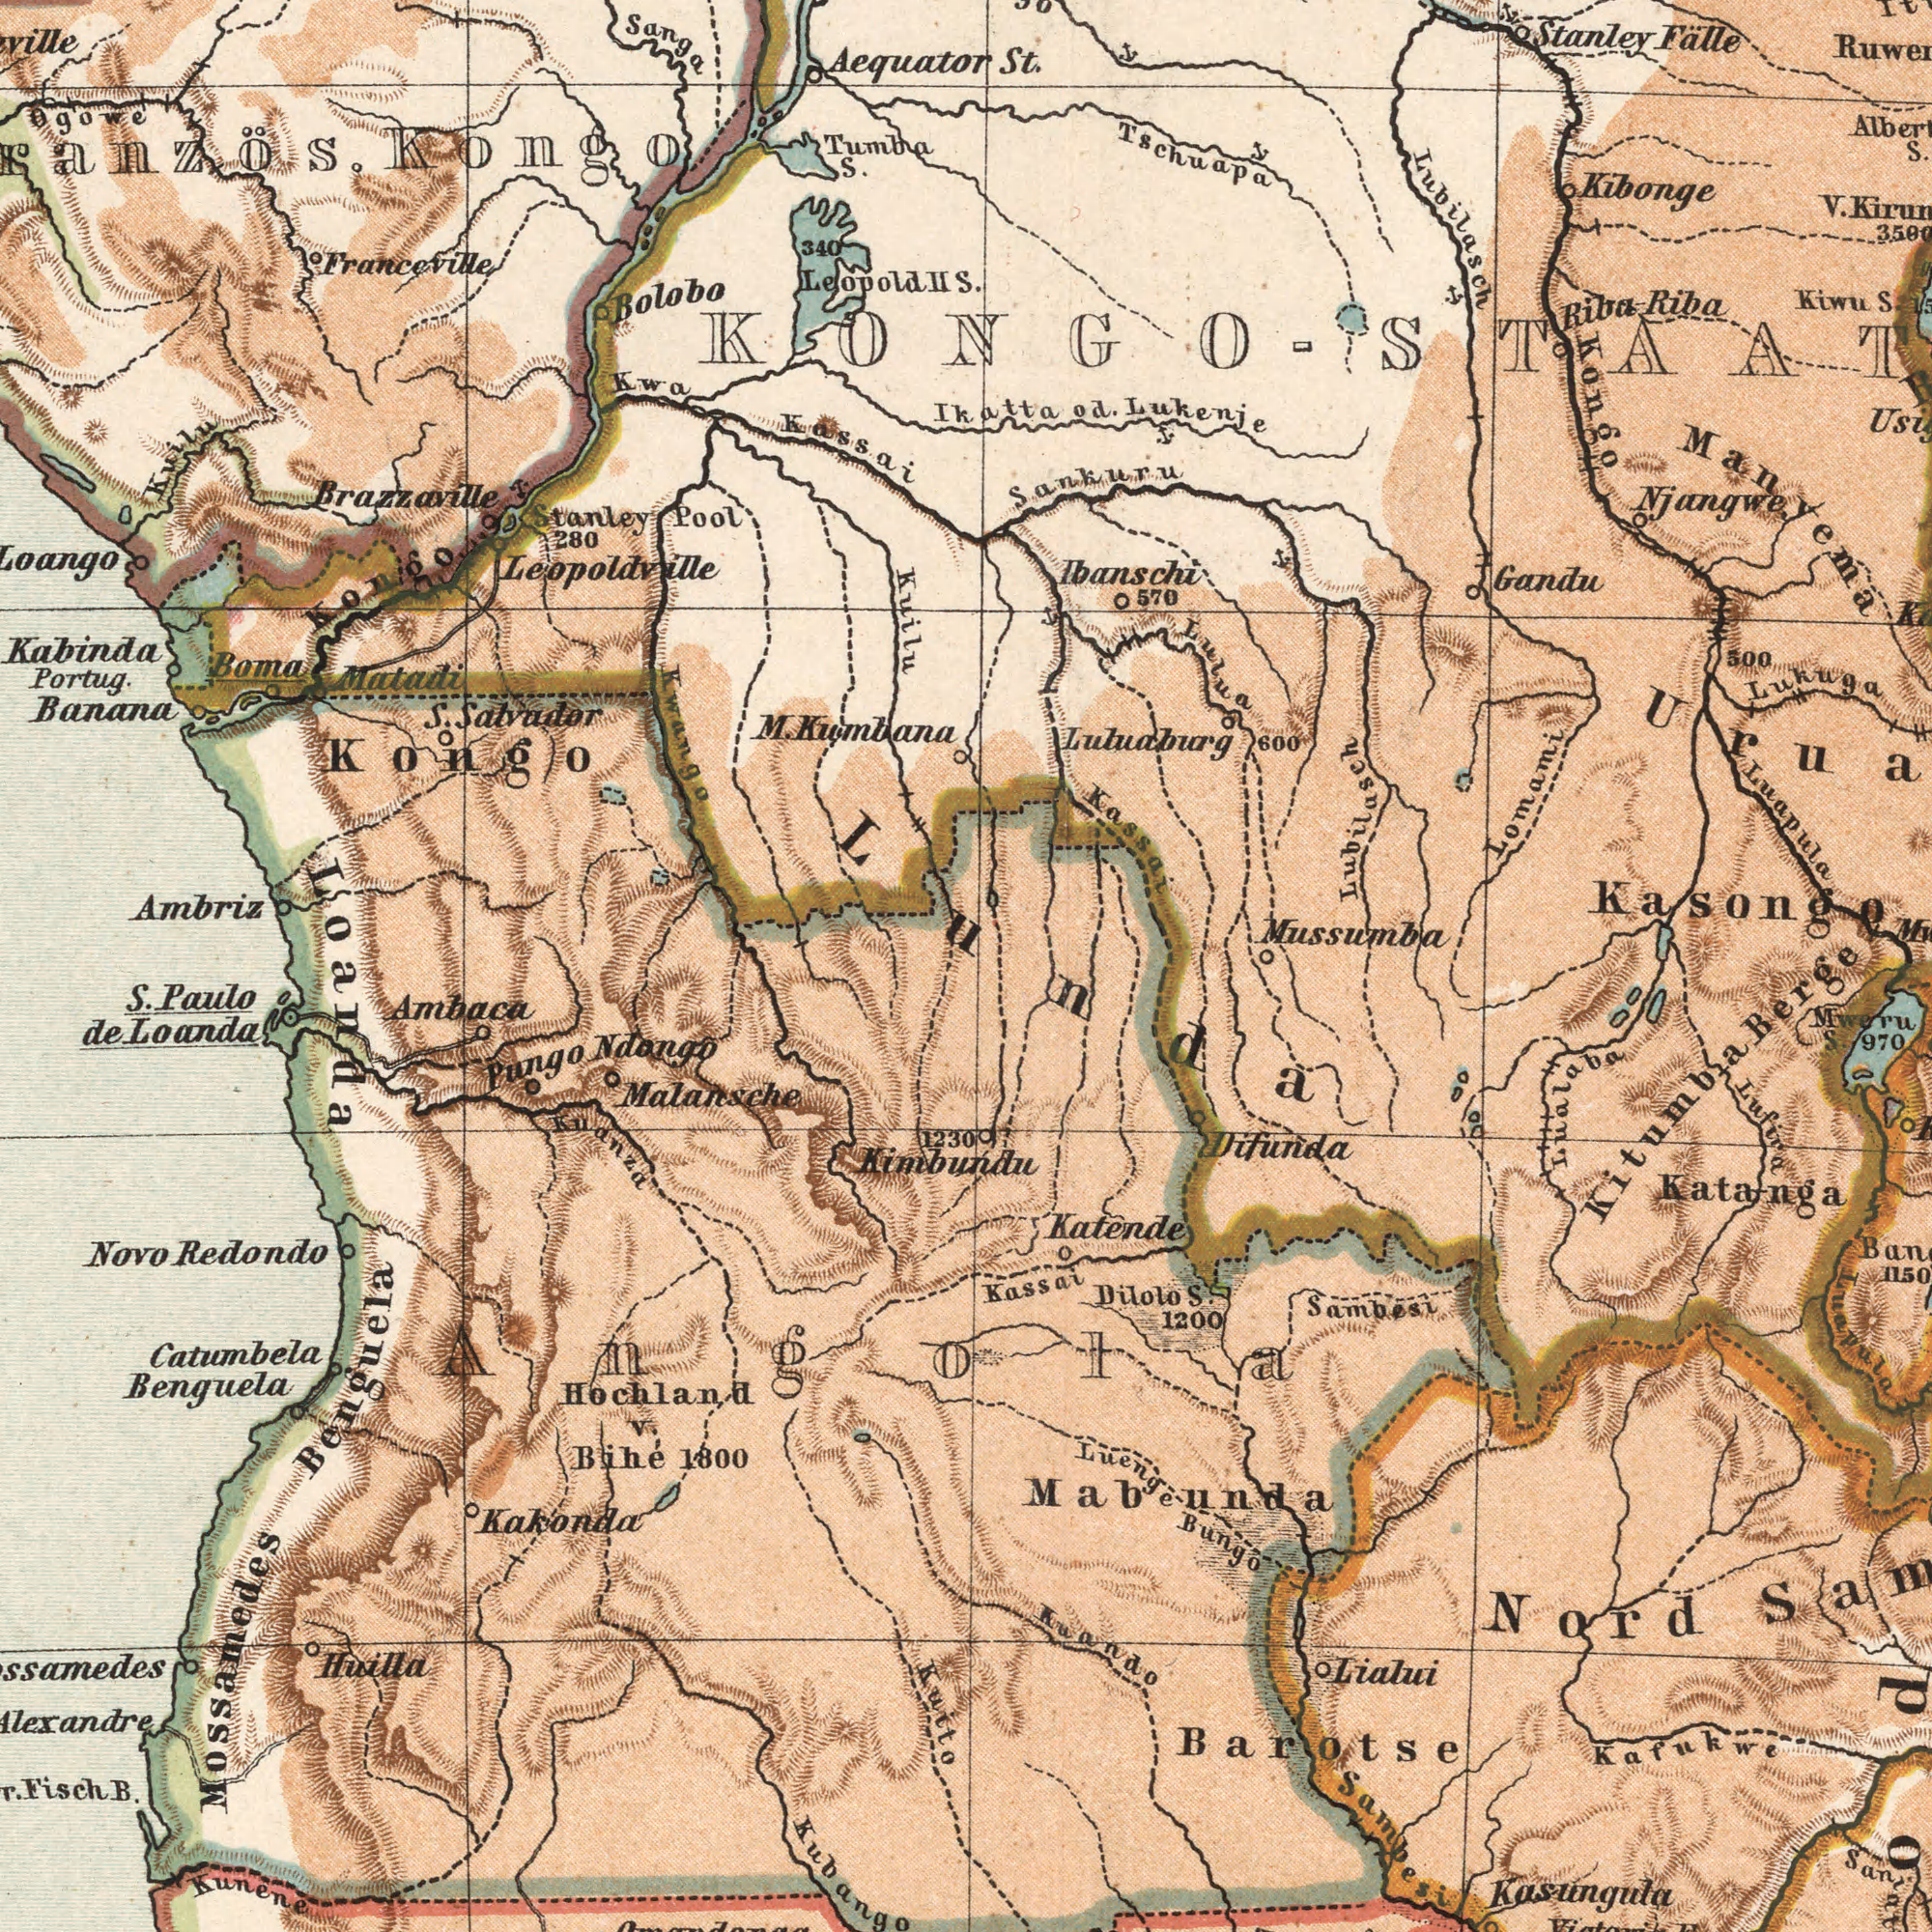What text can you see in the top-right section? Sankuru S. St. Ikatta od. Lukenje Mussumba Lubuaburg Luapula Stanley Falle Riba Riba Kibonge 500 Lukuga Lomami Ibanschi 570 Lubilasch Kongo Njangwe Lubilasch Gandu Kiwu S. V. Lulua 600 Tschuapa Manyema Kasongo Kassai KONGO-STAAT What text is visible in the lower-left corner? Fisch B. Hochland V. Bihé 1800 Kakonda Pungo Ndango Malansche Catumbela Benguela Ambaca S. Paulo de Loanda Novo Redondo Kuito 1230 Kimbundu Huilla Kuanza Kunene Loanda Mossamedes Benguela Kubango Angola What text can you see in the top-left section? Brazzaville Kongo M. Kumbana Kwango Kabinda Portug. Banana S. Salvador Boma Matadi Tumba S. Kwa Kassai 340 Leopold II Aequator Bolobo Loango Stanley Pool 280 Kongo Sanga Franceville Ambriz Kuilu Leopoldville Kuilu Ogowe Kongo What text can you see in the bottom-right section? Barotse Kasungula Kuando Nord Sambesi Lufira Kafukwe Kassai Luenge Bungo Mabunda Mweru S. 970 Lialui Dilolo S. 1200 Lualaba Difunda Kitumba Berge Sambesi Katanga Lnuapula Katende Lunda 